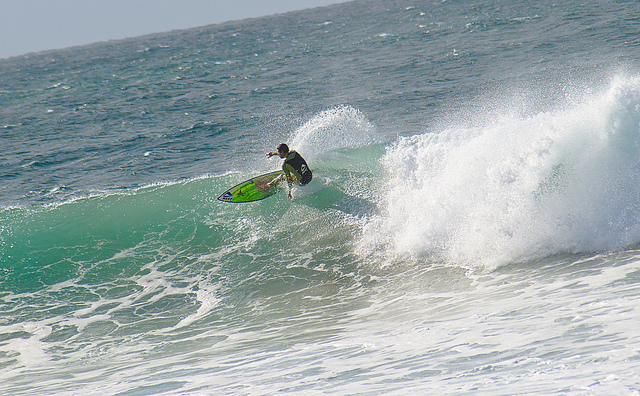How many people are surfing? There is one person surfing, expertly riding a wave with impressive skill and balance. 